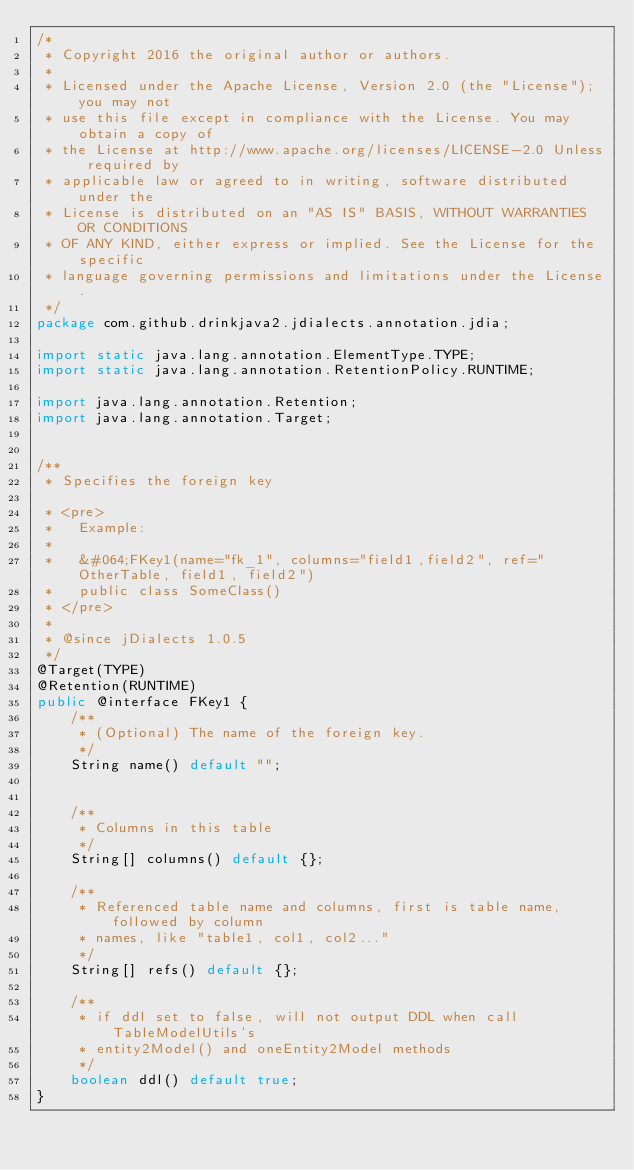Convert code to text. <code><loc_0><loc_0><loc_500><loc_500><_Java_>/*
 * Copyright 2016 the original author or authors.
 *
 * Licensed under the Apache License, Version 2.0 (the "License"); you may not
 * use this file except in compliance with the License. You may obtain a copy of
 * the License at http://www.apache.org/licenses/LICENSE-2.0 Unless required by
 * applicable law or agreed to in writing, software distributed under the
 * License is distributed on an "AS IS" BASIS, WITHOUT WARRANTIES OR CONDITIONS
 * OF ANY KIND, either express or implied. See the License for the specific
 * language governing permissions and limitations under the License.
 */
package com.github.drinkjava2.jdialects.annotation.jdia;

import static java.lang.annotation.ElementType.TYPE;
import static java.lang.annotation.RetentionPolicy.RUNTIME;

import java.lang.annotation.Retention;
import java.lang.annotation.Target;

 
/**
 * Specifies the foreign key
  
 * <pre>
 *   Example:
 *
 *   &#064;FKey1(name="fk_1", columns="field1,field2", ref="OtherTable, field1, field2")
 *   public class SomeClass()
 * </pre> 
 *
 * @since jDialects 1.0.5
 */
@Target(TYPE) 
@Retention(RUNTIME)
public @interface FKey1 {
    /**
     * (Optional) The name of the foreign key. 
     */
    String name() default "";
 

    /**
     * Columns in this table
     */
    String[] columns() default {};

	/**
	 * Referenced table name and columns, first is table name, followed by column
	 * names, like "table1, col1, col2..."
	 */
	String[] refs() default {};
	
	/**
	 * if ddl set to false, will not output DDL when call TableModelUtils's
	 * entity2Model() and oneEntity2Model methods
	 */
	boolean ddl() default true;
}
</code> 